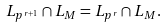<formula> <loc_0><loc_0><loc_500><loc_500>L _ { p ^ { r + 1 } } \cap L _ { M } = L _ { p ^ { r } } \cap L _ { M } .</formula> 